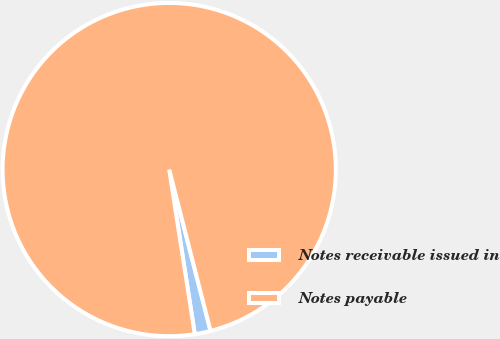Convert chart to OTSL. <chart><loc_0><loc_0><loc_500><loc_500><pie_chart><fcel>Notes receivable issued in<fcel>Notes payable<nl><fcel>1.54%<fcel>98.46%<nl></chart> 